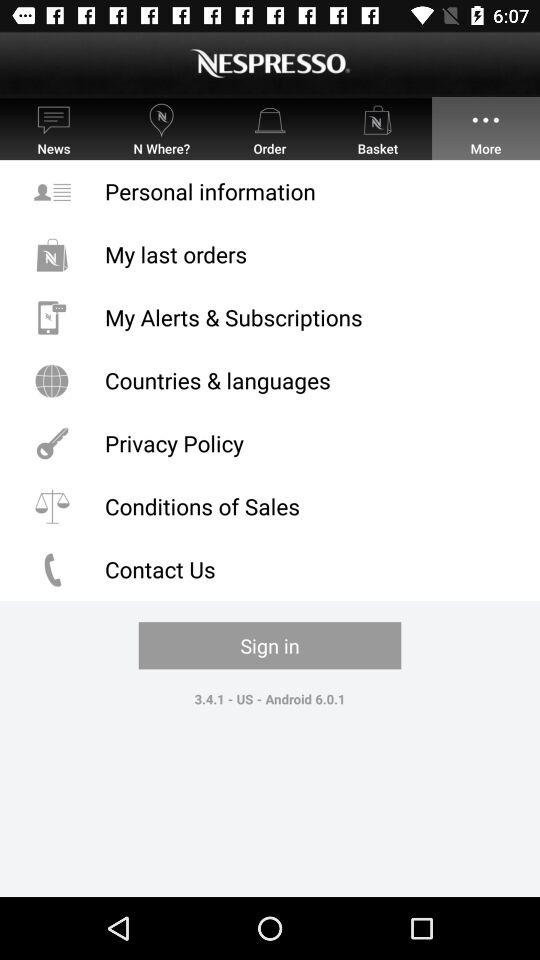What is the application name? The application name is "NESPRESSO". 